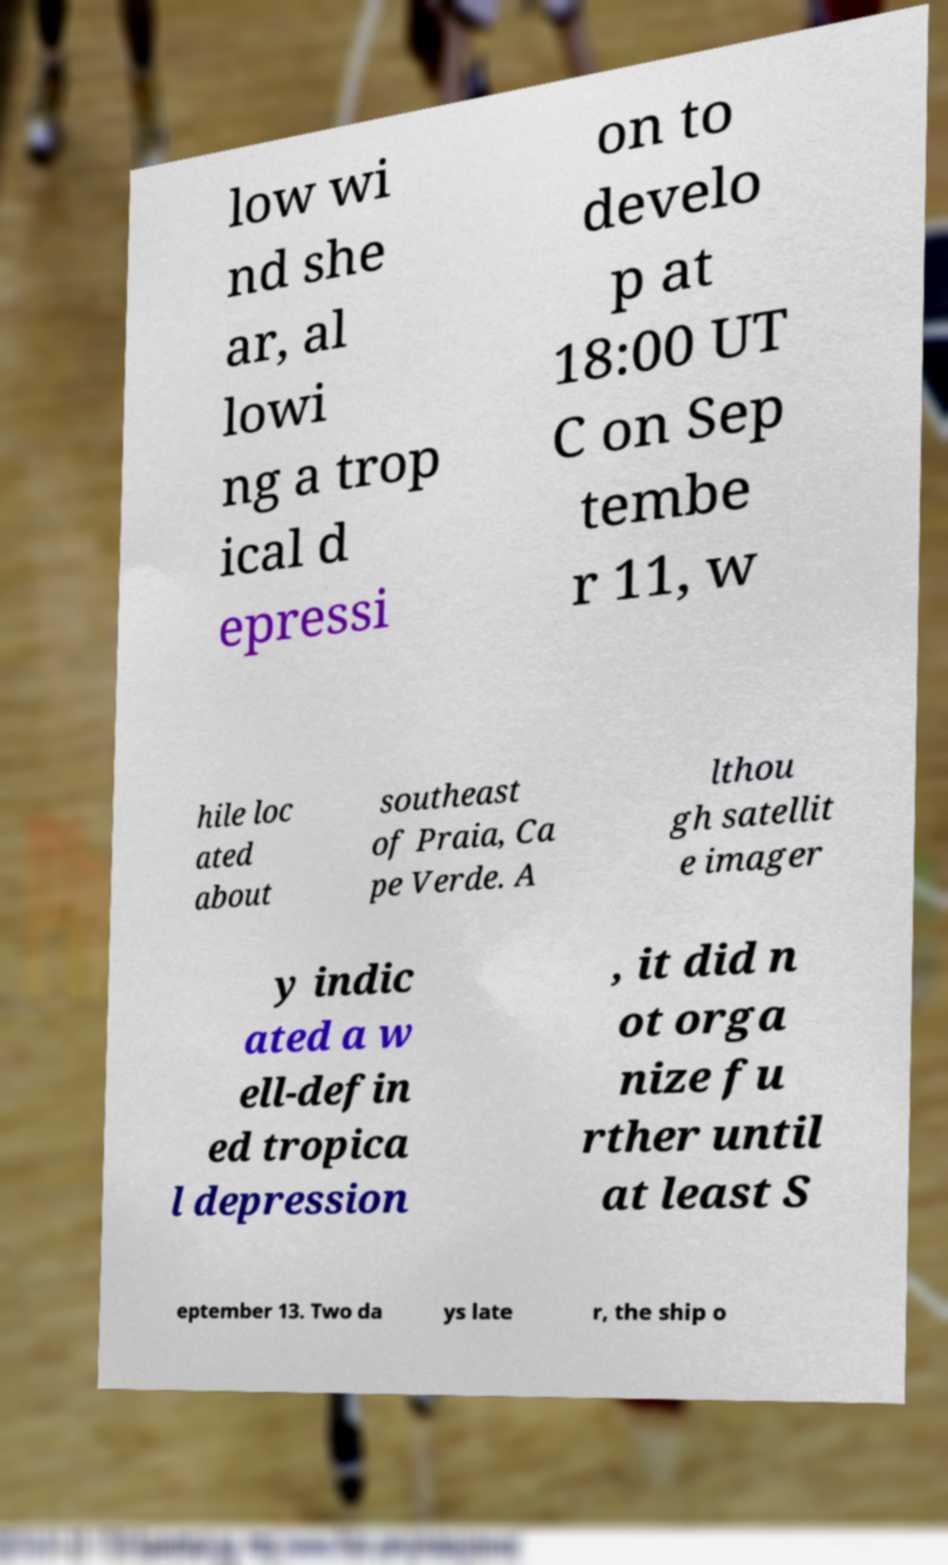Please read and relay the text visible in this image. What does it say? low wi nd she ar, al lowi ng a trop ical d epressi on to develo p at 18:00 UT C on Sep tembe r 11, w hile loc ated about southeast of Praia, Ca pe Verde. A lthou gh satellit e imager y indic ated a w ell-defin ed tropica l depression , it did n ot orga nize fu rther until at least S eptember 13. Two da ys late r, the ship o 